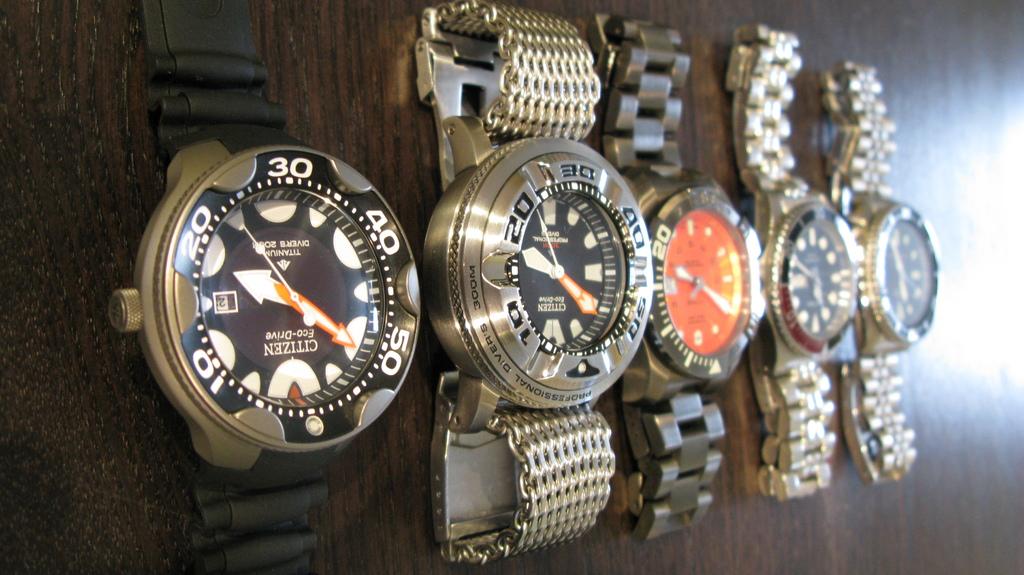What is the brand of the first watch?
Provide a short and direct response. Citizen. 